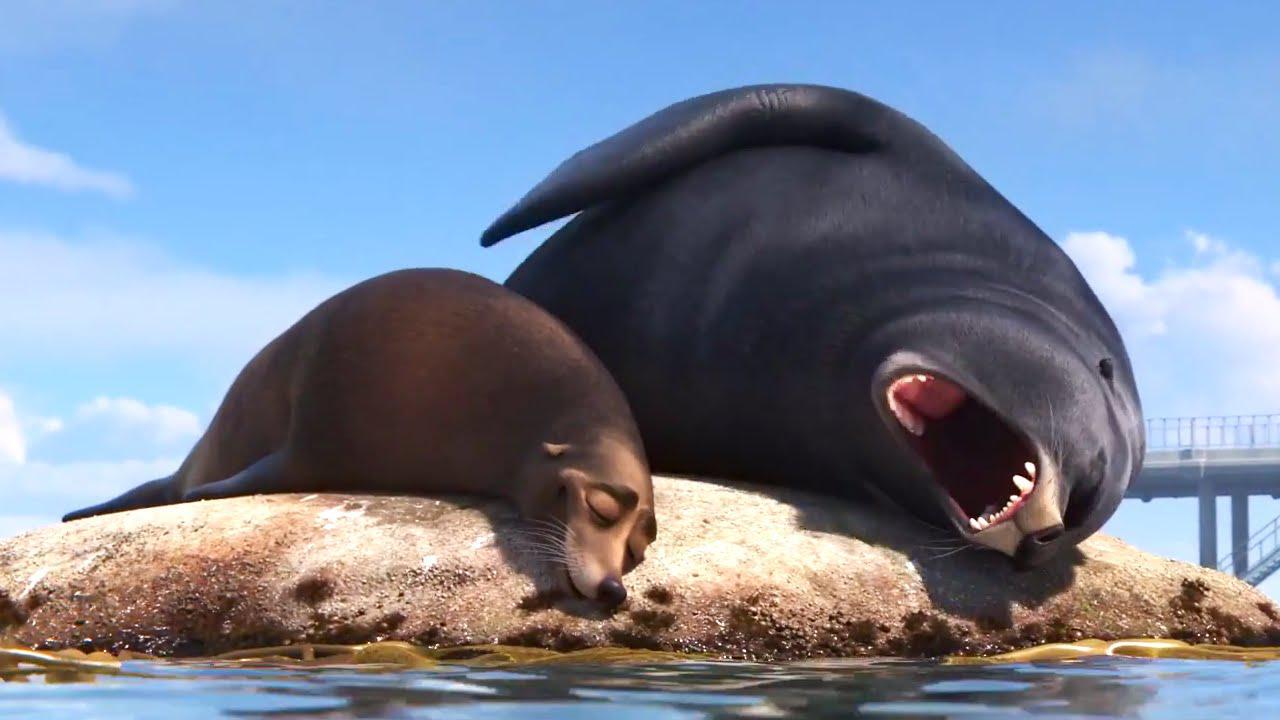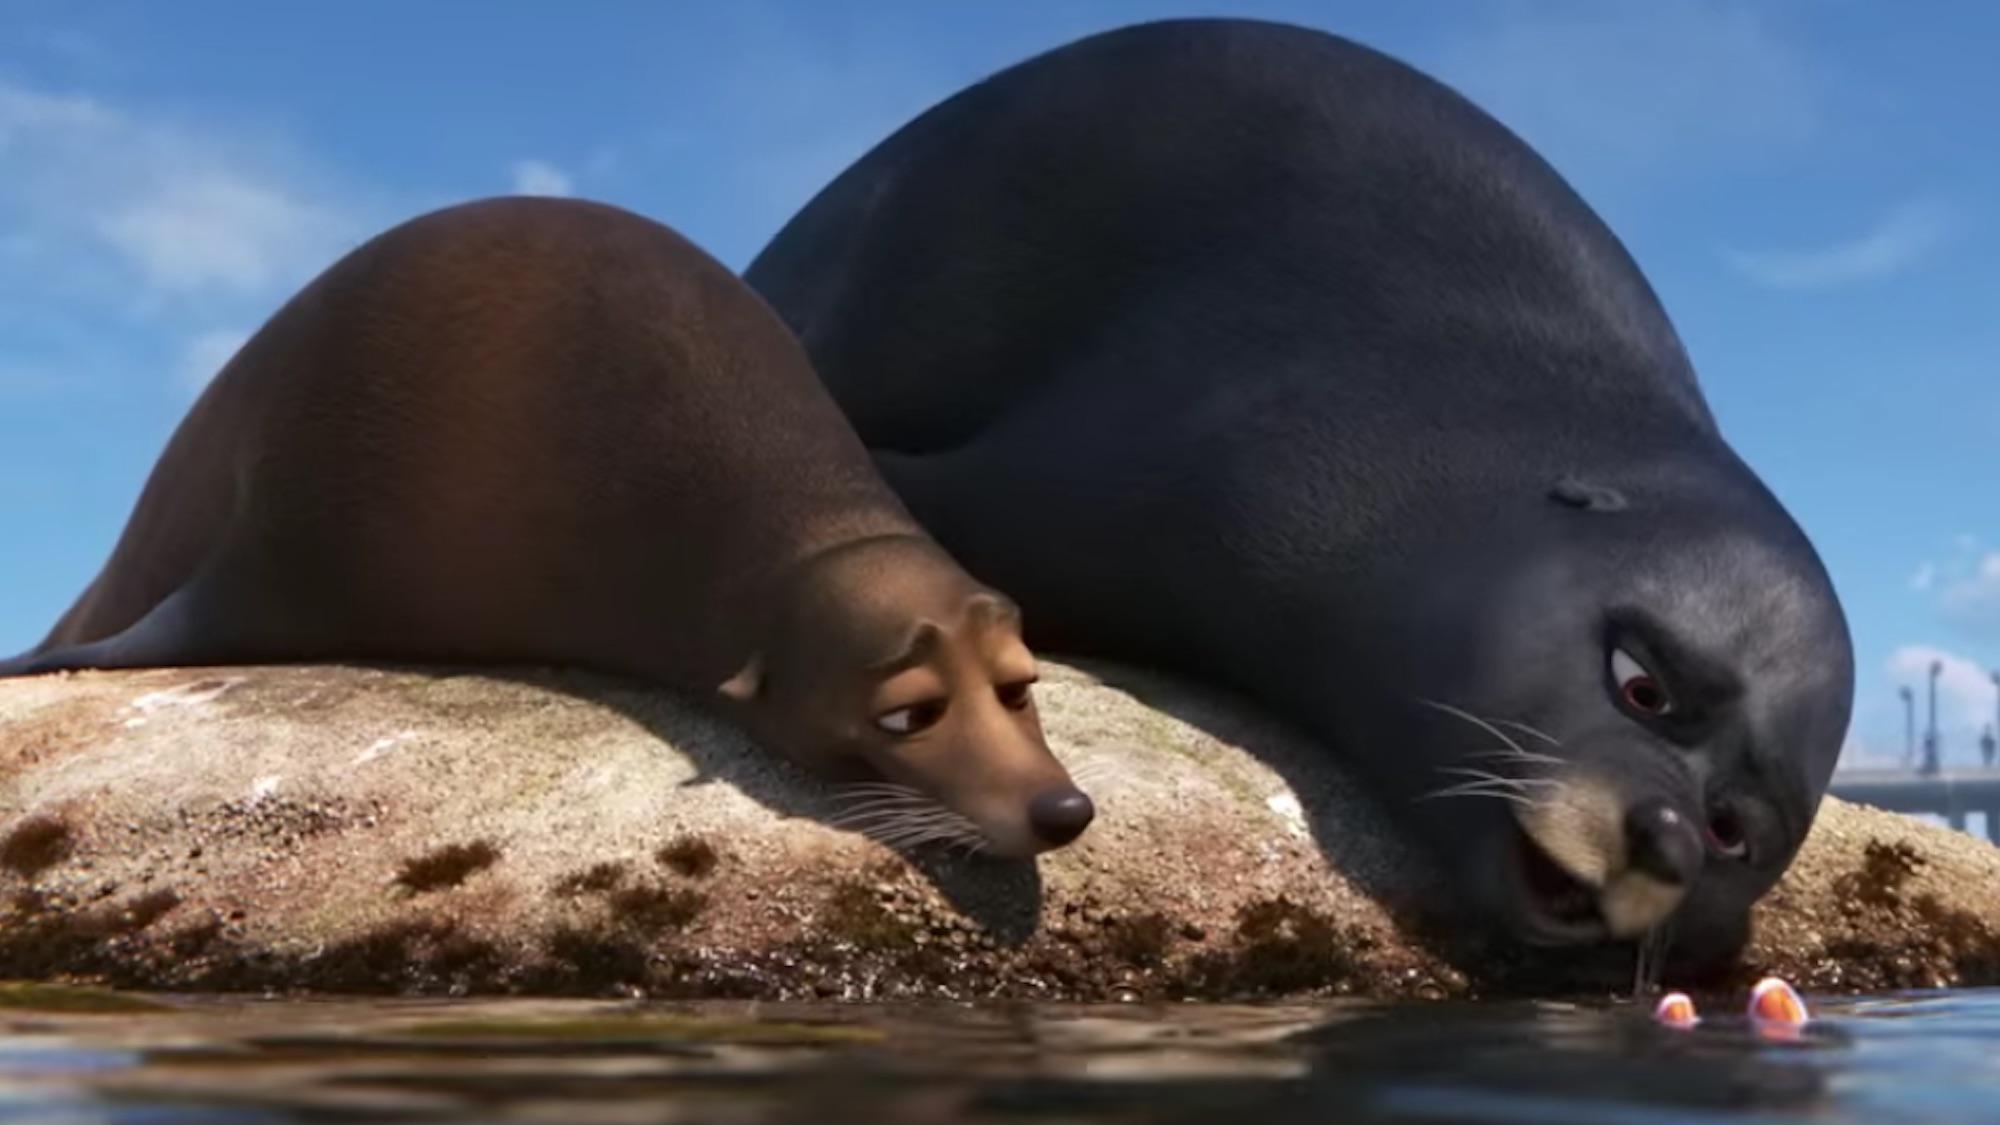The first image is the image on the left, the second image is the image on the right. For the images shown, is this caption "An image includes a large seal with wide-open mouth and a smaller seal with a closed mouth." true? Answer yes or no. Yes. 